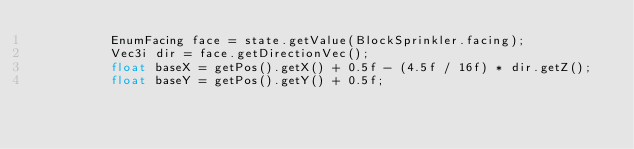Convert code to text. <code><loc_0><loc_0><loc_500><loc_500><_Java_>          EnumFacing face = state.getValue(BlockSprinkler.facing);
          Vec3i dir = face.getDirectionVec();
          float baseX = getPos().getX() + 0.5f - (4.5f / 16f) * dir.getZ();
          float baseY = getPos().getY() + 0.5f;</code> 